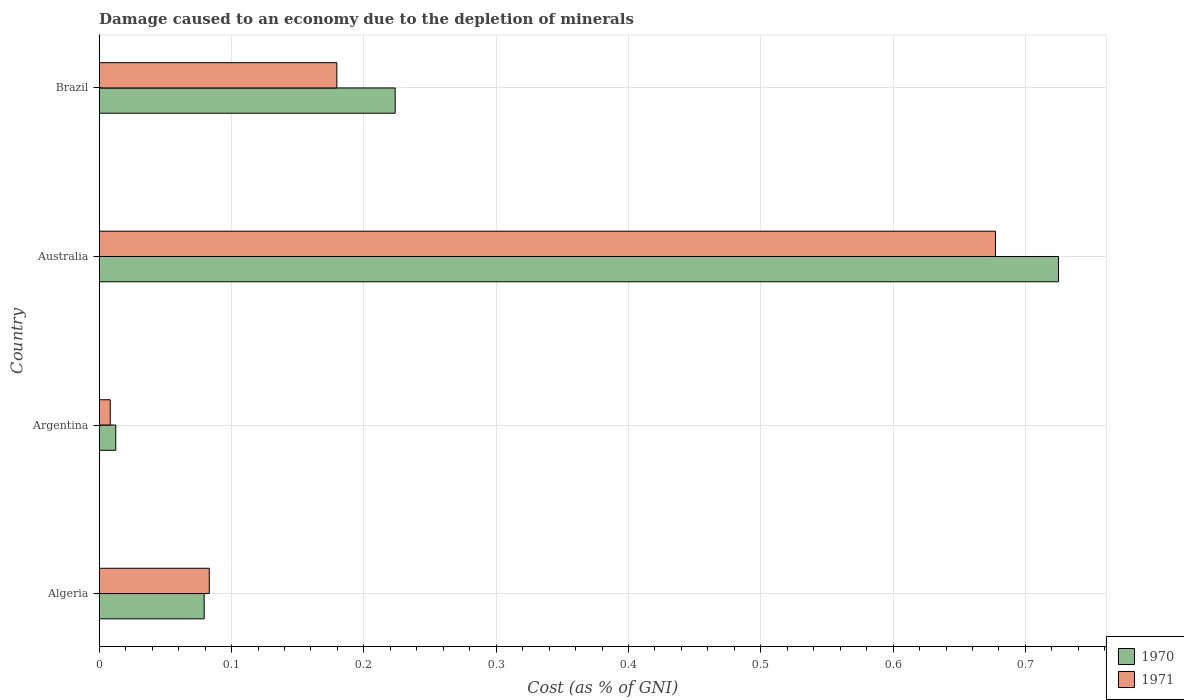How many different coloured bars are there?
Offer a very short reply. 2. What is the cost of damage caused due to the depletion of minerals in 1970 in Argentina?
Keep it short and to the point. 0.01. Across all countries, what is the maximum cost of damage caused due to the depletion of minerals in 1971?
Provide a short and direct response. 0.68. Across all countries, what is the minimum cost of damage caused due to the depletion of minerals in 1970?
Your answer should be compact. 0.01. In which country was the cost of damage caused due to the depletion of minerals in 1971 maximum?
Provide a succinct answer. Australia. What is the total cost of damage caused due to the depletion of minerals in 1970 in the graph?
Make the answer very short. 1.04. What is the difference between the cost of damage caused due to the depletion of minerals in 1971 in Australia and that in Brazil?
Your answer should be very brief. 0.5. What is the difference between the cost of damage caused due to the depletion of minerals in 1970 in Algeria and the cost of damage caused due to the depletion of minerals in 1971 in Australia?
Your response must be concise. -0.6. What is the average cost of damage caused due to the depletion of minerals in 1970 per country?
Give a very brief answer. 0.26. What is the difference between the cost of damage caused due to the depletion of minerals in 1970 and cost of damage caused due to the depletion of minerals in 1971 in Australia?
Give a very brief answer. 0.05. In how many countries, is the cost of damage caused due to the depletion of minerals in 1971 greater than 0.36000000000000004 %?
Offer a terse response. 1. What is the ratio of the cost of damage caused due to the depletion of minerals in 1971 in Argentina to that in Brazil?
Keep it short and to the point. 0.05. What is the difference between the highest and the second highest cost of damage caused due to the depletion of minerals in 1970?
Your response must be concise. 0.5. What is the difference between the highest and the lowest cost of damage caused due to the depletion of minerals in 1971?
Offer a terse response. 0.67. In how many countries, is the cost of damage caused due to the depletion of minerals in 1971 greater than the average cost of damage caused due to the depletion of minerals in 1971 taken over all countries?
Your answer should be very brief. 1. What does the 2nd bar from the top in Algeria represents?
Your response must be concise. 1970. Are all the bars in the graph horizontal?
Keep it short and to the point. Yes. What is the difference between two consecutive major ticks on the X-axis?
Ensure brevity in your answer.  0.1. Are the values on the major ticks of X-axis written in scientific E-notation?
Offer a very short reply. No. Does the graph contain any zero values?
Your answer should be very brief. No. Does the graph contain grids?
Your answer should be very brief. Yes. What is the title of the graph?
Provide a short and direct response. Damage caused to an economy due to the depletion of minerals. Does "1984" appear as one of the legend labels in the graph?
Your response must be concise. No. What is the label or title of the X-axis?
Keep it short and to the point. Cost (as % of GNI). What is the label or title of the Y-axis?
Ensure brevity in your answer.  Country. What is the Cost (as % of GNI) in 1970 in Algeria?
Your answer should be very brief. 0.08. What is the Cost (as % of GNI) of 1971 in Algeria?
Your response must be concise. 0.08. What is the Cost (as % of GNI) in 1970 in Argentina?
Provide a short and direct response. 0.01. What is the Cost (as % of GNI) of 1971 in Argentina?
Keep it short and to the point. 0.01. What is the Cost (as % of GNI) of 1970 in Australia?
Provide a succinct answer. 0.72. What is the Cost (as % of GNI) in 1971 in Australia?
Keep it short and to the point. 0.68. What is the Cost (as % of GNI) of 1970 in Brazil?
Provide a succinct answer. 0.22. What is the Cost (as % of GNI) in 1971 in Brazil?
Ensure brevity in your answer.  0.18. Across all countries, what is the maximum Cost (as % of GNI) in 1970?
Provide a short and direct response. 0.72. Across all countries, what is the maximum Cost (as % of GNI) of 1971?
Offer a very short reply. 0.68. Across all countries, what is the minimum Cost (as % of GNI) of 1970?
Provide a short and direct response. 0.01. Across all countries, what is the minimum Cost (as % of GNI) in 1971?
Your response must be concise. 0.01. What is the total Cost (as % of GNI) of 1970 in the graph?
Keep it short and to the point. 1.04. What is the total Cost (as % of GNI) of 1971 in the graph?
Make the answer very short. 0.95. What is the difference between the Cost (as % of GNI) of 1970 in Algeria and that in Argentina?
Keep it short and to the point. 0.07. What is the difference between the Cost (as % of GNI) of 1971 in Algeria and that in Argentina?
Provide a short and direct response. 0.07. What is the difference between the Cost (as % of GNI) of 1970 in Algeria and that in Australia?
Give a very brief answer. -0.65. What is the difference between the Cost (as % of GNI) in 1971 in Algeria and that in Australia?
Your answer should be very brief. -0.59. What is the difference between the Cost (as % of GNI) of 1970 in Algeria and that in Brazil?
Make the answer very short. -0.14. What is the difference between the Cost (as % of GNI) in 1971 in Algeria and that in Brazil?
Give a very brief answer. -0.1. What is the difference between the Cost (as % of GNI) in 1970 in Argentina and that in Australia?
Provide a succinct answer. -0.71. What is the difference between the Cost (as % of GNI) of 1971 in Argentina and that in Australia?
Give a very brief answer. -0.67. What is the difference between the Cost (as % of GNI) in 1970 in Argentina and that in Brazil?
Your response must be concise. -0.21. What is the difference between the Cost (as % of GNI) of 1971 in Argentina and that in Brazil?
Your answer should be very brief. -0.17. What is the difference between the Cost (as % of GNI) in 1970 in Australia and that in Brazil?
Your response must be concise. 0.5. What is the difference between the Cost (as % of GNI) in 1971 in Australia and that in Brazil?
Give a very brief answer. 0.5. What is the difference between the Cost (as % of GNI) in 1970 in Algeria and the Cost (as % of GNI) in 1971 in Argentina?
Keep it short and to the point. 0.07. What is the difference between the Cost (as % of GNI) of 1970 in Algeria and the Cost (as % of GNI) of 1971 in Australia?
Give a very brief answer. -0.6. What is the difference between the Cost (as % of GNI) in 1970 in Algeria and the Cost (as % of GNI) in 1971 in Brazil?
Make the answer very short. -0.1. What is the difference between the Cost (as % of GNI) of 1970 in Argentina and the Cost (as % of GNI) of 1971 in Australia?
Offer a terse response. -0.66. What is the difference between the Cost (as % of GNI) in 1970 in Argentina and the Cost (as % of GNI) in 1971 in Brazil?
Give a very brief answer. -0.17. What is the difference between the Cost (as % of GNI) in 1970 in Australia and the Cost (as % of GNI) in 1971 in Brazil?
Offer a terse response. 0.55. What is the average Cost (as % of GNI) of 1970 per country?
Keep it short and to the point. 0.26. What is the average Cost (as % of GNI) of 1971 per country?
Ensure brevity in your answer.  0.24. What is the difference between the Cost (as % of GNI) in 1970 and Cost (as % of GNI) in 1971 in Algeria?
Offer a very short reply. -0. What is the difference between the Cost (as % of GNI) of 1970 and Cost (as % of GNI) of 1971 in Argentina?
Ensure brevity in your answer.  0. What is the difference between the Cost (as % of GNI) in 1970 and Cost (as % of GNI) in 1971 in Australia?
Your answer should be very brief. 0.05. What is the difference between the Cost (as % of GNI) of 1970 and Cost (as % of GNI) of 1971 in Brazil?
Provide a short and direct response. 0.04. What is the ratio of the Cost (as % of GNI) in 1970 in Algeria to that in Argentina?
Provide a short and direct response. 6.35. What is the ratio of the Cost (as % of GNI) in 1971 in Algeria to that in Argentina?
Provide a short and direct response. 9.99. What is the ratio of the Cost (as % of GNI) of 1970 in Algeria to that in Australia?
Provide a succinct answer. 0.11. What is the ratio of the Cost (as % of GNI) of 1971 in Algeria to that in Australia?
Provide a short and direct response. 0.12. What is the ratio of the Cost (as % of GNI) of 1970 in Algeria to that in Brazil?
Give a very brief answer. 0.35. What is the ratio of the Cost (as % of GNI) in 1971 in Algeria to that in Brazil?
Provide a short and direct response. 0.46. What is the ratio of the Cost (as % of GNI) of 1970 in Argentina to that in Australia?
Offer a very short reply. 0.02. What is the ratio of the Cost (as % of GNI) in 1971 in Argentina to that in Australia?
Give a very brief answer. 0.01. What is the ratio of the Cost (as % of GNI) of 1970 in Argentina to that in Brazil?
Your response must be concise. 0.06. What is the ratio of the Cost (as % of GNI) in 1971 in Argentina to that in Brazil?
Make the answer very short. 0.05. What is the ratio of the Cost (as % of GNI) of 1970 in Australia to that in Brazil?
Ensure brevity in your answer.  3.24. What is the ratio of the Cost (as % of GNI) of 1971 in Australia to that in Brazil?
Offer a terse response. 3.77. What is the difference between the highest and the second highest Cost (as % of GNI) in 1970?
Keep it short and to the point. 0.5. What is the difference between the highest and the second highest Cost (as % of GNI) in 1971?
Your answer should be compact. 0.5. What is the difference between the highest and the lowest Cost (as % of GNI) of 1970?
Keep it short and to the point. 0.71. What is the difference between the highest and the lowest Cost (as % of GNI) of 1971?
Your response must be concise. 0.67. 